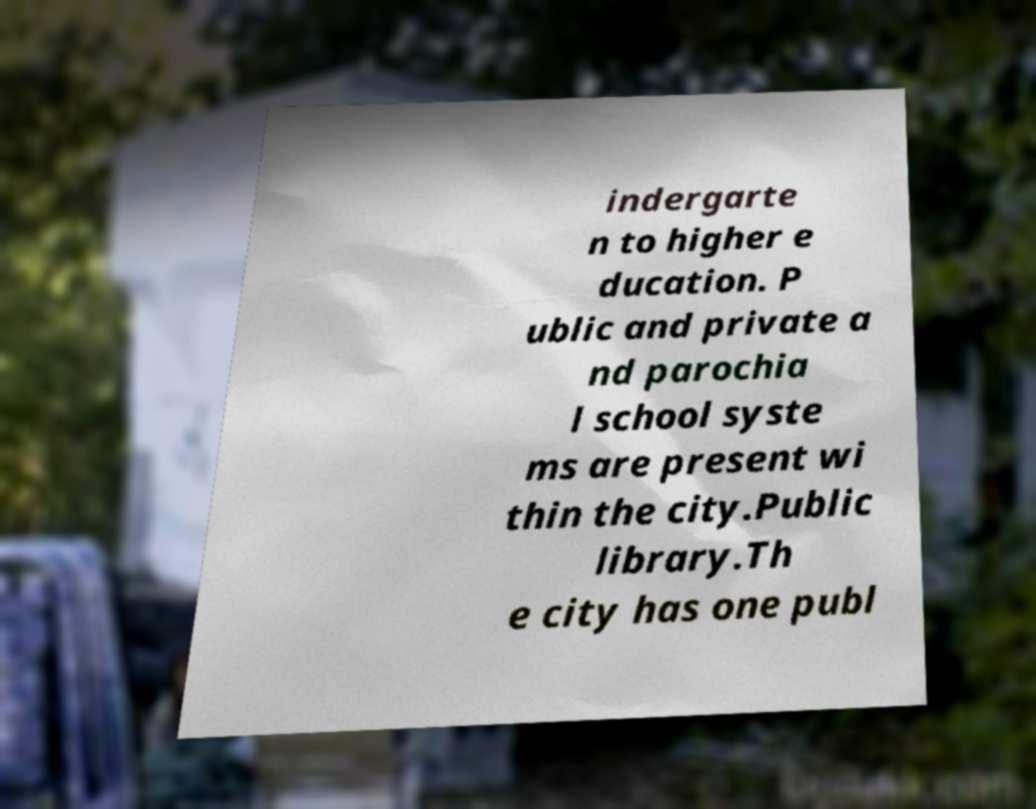Can you accurately transcribe the text from the provided image for me? indergarte n to higher e ducation. P ublic and private a nd parochia l school syste ms are present wi thin the city.Public library.Th e city has one publ 